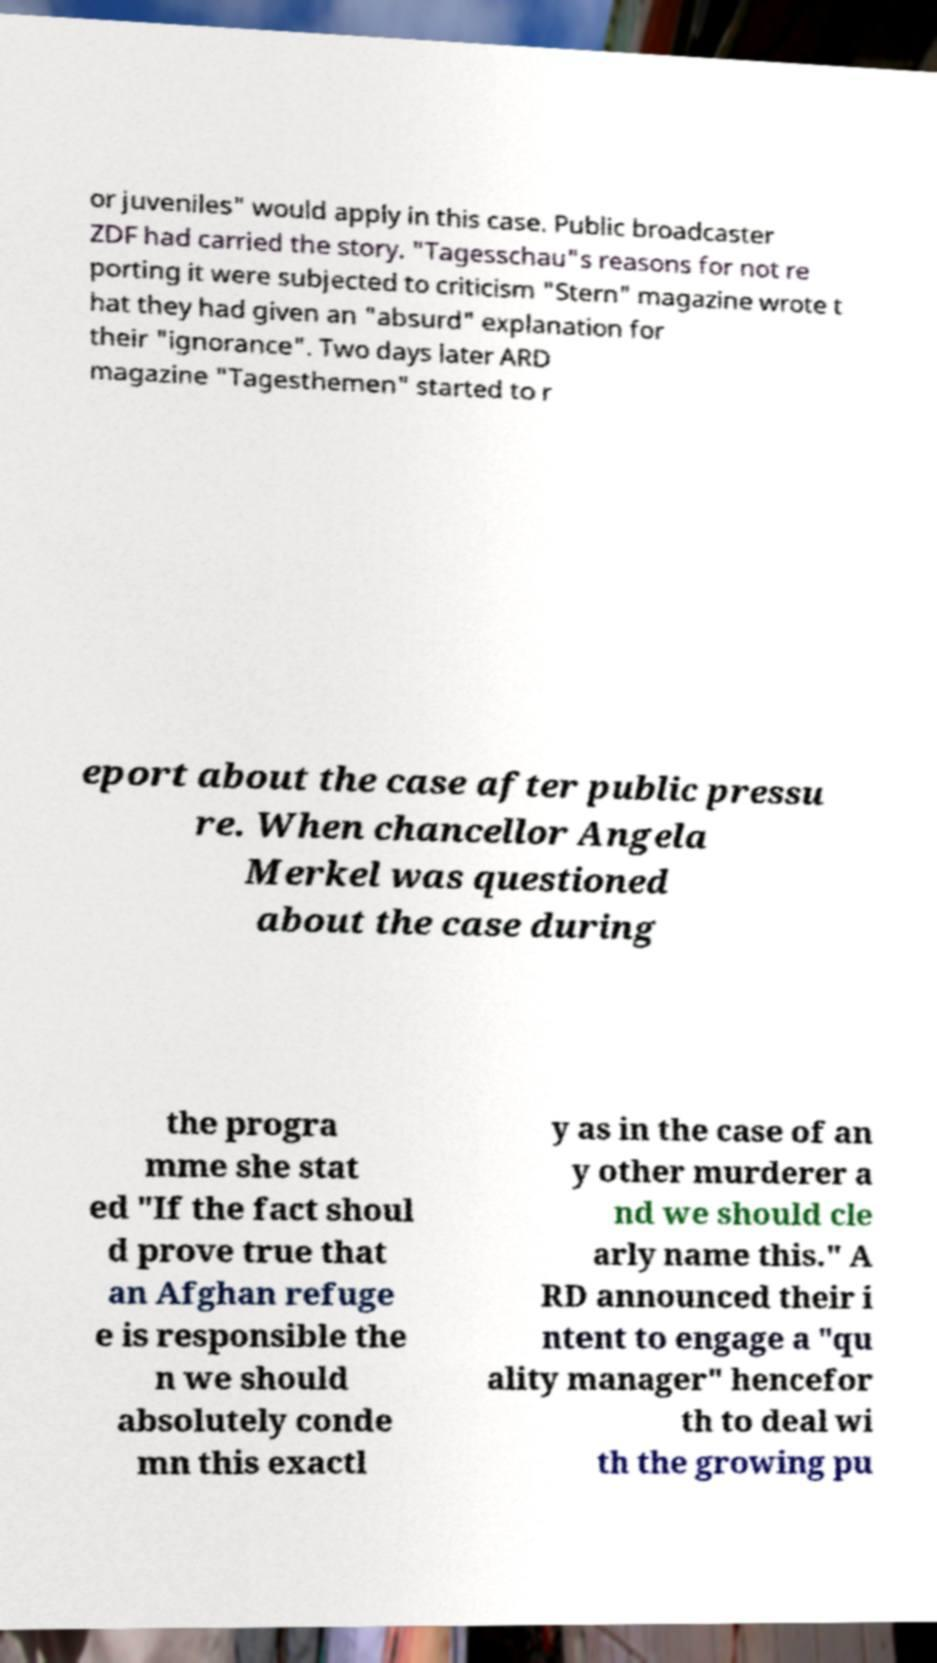Can you read and provide the text displayed in the image?This photo seems to have some interesting text. Can you extract and type it out for me? or juveniles" would apply in this case. Public broadcaster ZDF had carried the story. "Tagesschau"s reasons for not re porting it were subjected to criticism "Stern" magazine wrote t hat they had given an "absurd" explanation for their "ignorance". Two days later ARD magazine "Tagesthemen" started to r eport about the case after public pressu re. When chancellor Angela Merkel was questioned about the case during the progra mme she stat ed "If the fact shoul d prove true that an Afghan refuge e is responsible the n we should absolutely conde mn this exactl y as in the case of an y other murderer a nd we should cle arly name this." A RD announced their i ntent to engage a "qu ality manager" hencefor th to deal wi th the growing pu 